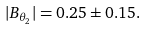Convert formula to latex. <formula><loc_0><loc_0><loc_500><loc_500>| B _ { \theta _ { 2 } } | = 0 . 2 5 \pm 0 . 1 5 .</formula> 